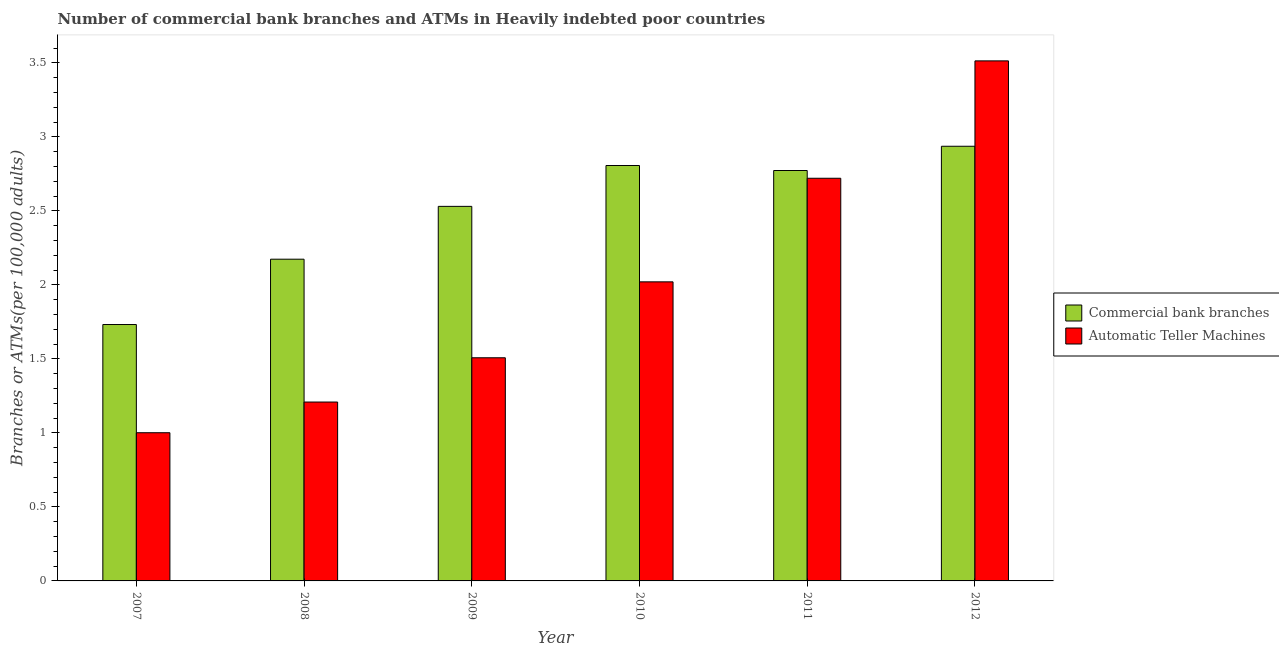How many different coloured bars are there?
Keep it short and to the point. 2. How many groups of bars are there?
Give a very brief answer. 6. Are the number of bars per tick equal to the number of legend labels?
Provide a short and direct response. Yes. How many bars are there on the 1st tick from the right?
Offer a very short reply. 2. What is the label of the 2nd group of bars from the left?
Your answer should be compact. 2008. In how many cases, is the number of bars for a given year not equal to the number of legend labels?
Provide a succinct answer. 0. What is the number of atms in 2010?
Offer a very short reply. 2.02. Across all years, what is the maximum number of commercal bank branches?
Keep it short and to the point. 2.94. Across all years, what is the minimum number of commercal bank branches?
Offer a very short reply. 1.73. What is the total number of commercal bank branches in the graph?
Offer a very short reply. 14.95. What is the difference between the number of commercal bank branches in 2008 and that in 2012?
Keep it short and to the point. -0.76. What is the difference between the number of commercal bank branches in 2009 and the number of atms in 2007?
Provide a succinct answer. 0.8. What is the average number of commercal bank branches per year?
Keep it short and to the point. 2.49. What is the ratio of the number of atms in 2007 to that in 2012?
Keep it short and to the point. 0.28. Is the number of atms in 2008 less than that in 2010?
Make the answer very short. Yes. Is the difference between the number of commercal bank branches in 2008 and 2009 greater than the difference between the number of atms in 2008 and 2009?
Offer a terse response. No. What is the difference between the highest and the second highest number of atms?
Offer a very short reply. 0.79. What is the difference between the highest and the lowest number of commercal bank branches?
Your answer should be compact. 1.2. In how many years, is the number of atms greater than the average number of atms taken over all years?
Provide a succinct answer. 3. Is the sum of the number of atms in 2007 and 2011 greater than the maximum number of commercal bank branches across all years?
Offer a terse response. Yes. What does the 1st bar from the left in 2008 represents?
Offer a terse response. Commercial bank branches. What does the 1st bar from the right in 2010 represents?
Keep it short and to the point. Automatic Teller Machines. How many bars are there?
Offer a very short reply. 12. Are all the bars in the graph horizontal?
Give a very brief answer. No. How many years are there in the graph?
Keep it short and to the point. 6. Are the values on the major ticks of Y-axis written in scientific E-notation?
Provide a succinct answer. No. Does the graph contain grids?
Offer a terse response. No. How many legend labels are there?
Keep it short and to the point. 2. What is the title of the graph?
Provide a succinct answer. Number of commercial bank branches and ATMs in Heavily indebted poor countries. What is the label or title of the Y-axis?
Your answer should be compact. Branches or ATMs(per 100,0 adults). What is the Branches or ATMs(per 100,000 adults) of Commercial bank branches in 2007?
Provide a succinct answer. 1.73. What is the Branches or ATMs(per 100,000 adults) in Automatic Teller Machines in 2007?
Offer a terse response. 1. What is the Branches or ATMs(per 100,000 adults) in Commercial bank branches in 2008?
Provide a succinct answer. 2.17. What is the Branches or ATMs(per 100,000 adults) in Automatic Teller Machines in 2008?
Provide a succinct answer. 1.21. What is the Branches or ATMs(per 100,000 adults) in Commercial bank branches in 2009?
Your answer should be very brief. 2.53. What is the Branches or ATMs(per 100,000 adults) of Automatic Teller Machines in 2009?
Your response must be concise. 1.51. What is the Branches or ATMs(per 100,000 adults) of Commercial bank branches in 2010?
Your answer should be compact. 2.81. What is the Branches or ATMs(per 100,000 adults) of Automatic Teller Machines in 2010?
Give a very brief answer. 2.02. What is the Branches or ATMs(per 100,000 adults) of Commercial bank branches in 2011?
Provide a short and direct response. 2.77. What is the Branches or ATMs(per 100,000 adults) of Automatic Teller Machines in 2011?
Ensure brevity in your answer.  2.72. What is the Branches or ATMs(per 100,000 adults) in Commercial bank branches in 2012?
Your response must be concise. 2.94. What is the Branches or ATMs(per 100,000 adults) of Automatic Teller Machines in 2012?
Provide a succinct answer. 3.51. Across all years, what is the maximum Branches or ATMs(per 100,000 adults) of Commercial bank branches?
Ensure brevity in your answer.  2.94. Across all years, what is the maximum Branches or ATMs(per 100,000 adults) in Automatic Teller Machines?
Keep it short and to the point. 3.51. Across all years, what is the minimum Branches or ATMs(per 100,000 adults) in Commercial bank branches?
Your response must be concise. 1.73. Across all years, what is the minimum Branches or ATMs(per 100,000 adults) of Automatic Teller Machines?
Your answer should be compact. 1. What is the total Branches or ATMs(per 100,000 adults) of Commercial bank branches in the graph?
Your response must be concise. 14.95. What is the total Branches or ATMs(per 100,000 adults) of Automatic Teller Machines in the graph?
Ensure brevity in your answer.  11.97. What is the difference between the Branches or ATMs(per 100,000 adults) of Commercial bank branches in 2007 and that in 2008?
Your answer should be compact. -0.44. What is the difference between the Branches or ATMs(per 100,000 adults) in Automatic Teller Machines in 2007 and that in 2008?
Your answer should be very brief. -0.21. What is the difference between the Branches or ATMs(per 100,000 adults) of Commercial bank branches in 2007 and that in 2009?
Give a very brief answer. -0.8. What is the difference between the Branches or ATMs(per 100,000 adults) of Automatic Teller Machines in 2007 and that in 2009?
Offer a terse response. -0.51. What is the difference between the Branches or ATMs(per 100,000 adults) of Commercial bank branches in 2007 and that in 2010?
Make the answer very short. -1.07. What is the difference between the Branches or ATMs(per 100,000 adults) in Automatic Teller Machines in 2007 and that in 2010?
Your answer should be compact. -1.02. What is the difference between the Branches or ATMs(per 100,000 adults) of Commercial bank branches in 2007 and that in 2011?
Your answer should be compact. -1.04. What is the difference between the Branches or ATMs(per 100,000 adults) in Automatic Teller Machines in 2007 and that in 2011?
Ensure brevity in your answer.  -1.72. What is the difference between the Branches or ATMs(per 100,000 adults) in Commercial bank branches in 2007 and that in 2012?
Keep it short and to the point. -1.2. What is the difference between the Branches or ATMs(per 100,000 adults) of Automatic Teller Machines in 2007 and that in 2012?
Your answer should be very brief. -2.51. What is the difference between the Branches or ATMs(per 100,000 adults) of Commercial bank branches in 2008 and that in 2009?
Keep it short and to the point. -0.36. What is the difference between the Branches or ATMs(per 100,000 adults) of Automatic Teller Machines in 2008 and that in 2009?
Give a very brief answer. -0.3. What is the difference between the Branches or ATMs(per 100,000 adults) of Commercial bank branches in 2008 and that in 2010?
Offer a very short reply. -0.63. What is the difference between the Branches or ATMs(per 100,000 adults) in Automatic Teller Machines in 2008 and that in 2010?
Your response must be concise. -0.81. What is the difference between the Branches or ATMs(per 100,000 adults) of Commercial bank branches in 2008 and that in 2011?
Your response must be concise. -0.6. What is the difference between the Branches or ATMs(per 100,000 adults) of Automatic Teller Machines in 2008 and that in 2011?
Give a very brief answer. -1.51. What is the difference between the Branches or ATMs(per 100,000 adults) of Commercial bank branches in 2008 and that in 2012?
Your answer should be compact. -0.76. What is the difference between the Branches or ATMs(per 100,000 adults) in Automatic Teller Machines in 2008 and that in 2012?
Your response must be concise. -2.31. What is the difference between the Branches or ATMs(per 100,000 adults) in Commercial bank branches in 2009 and that in 2010?
Your response must be concise. -0.28. What is the difference between the Branches or ATMs(per 100,000 adults) in Automatic Teller Machines in 2009 and that in 2010?
Offer a very short reply. -0.51. What is the difference between the Branches or ATMs(per 100,000 adults) of Commercial bank branches in 2009 and that in 2011?
Your answer should be very brief. -0.24. What is the difference between the Branches or ATMs(per 100,000 adults) in Automatic Teller Machines in 2009 and that in 2011?
Your answer should be very brief. -1.21. What is the difference between the Branches or ATMs(per 100,000 adults) in Commercial bank branches in 2009 and that in 2012?
Provide a short and direct response. -0.41. What is the difference between the Branches or ATMs(per 100,000 adults) in Automatic Teller Machines in 2009 and that in 2012?
Offer a very short reply. -2.01. What is the difference between the Branches or ATMs(per 100,000 adults) of Commercial bank branches in 2010 and that in 2011?
Offer a terse response. 0.03. What is the difference between the Branches or ATMs(per 100,000 adults) of Automatic Teller Machines in 2010 and that in 2011?
Provide a short and direct response. -0.7. What is the difference between the Branches or ATMs(per 100,000 adults) of Commercial bank branches in 2010 and that in 2012?
Ensure brevity in your answer.  -0.13. What is the difference between the Branches or ATMs(per 100,000 adults) in Automatic Teller Machines in 2010 and that in 2012?
Offer a terse response. -1.49. What is the difference between the Branches or ATMs(per 100,000 adults) in Commercial bank branches in 2011 and that in 2012?
Your answer should be compact. -0.16. What is the difference between the Branches or ATMs(per 100,000 adults) of Automatic Teller Machines in 2011 and that in 2012?
Your response must be concise. -0.79. What is the difference between the Branches or ATMs(per 100,000 adults) of Commercial bank branches in 2007 and the Branches or ATMs(per 100,000 adults) of Automatic Teller Machines in 2008?
Give a very brief answer. 0.52. What is the difference between the Branches or ATMs(per 100,000 adults) in Commercial bank branches in 2007 and the Branches or ATMs(per 100,000 adults) in Automatic Teller Machines in 2009?
Offer a terse response. 0.22. What is the difference between the Branches or ATMs(per 100,000 adults) of Commercial bank branches in 2007 and the Branches or ATMs(per 100,000 adults) of Automatic Teller Machines in 2010?
Offer a terse response. -0.29. What is the difference between the Branches or ATMs(per 100,000 adults) in Commercial bank branches in 2007 and the Branches or ATMs(per 100,000 adults) in Automatic Teller Machines in 2011?
Your response must be concise. -0.99. What is the difference between the Branches or ATMs(per 100,000 adults) in Commercial bank branches in 2007 and the Branches or ATMs(per 100,000 adults) in Automatic Teller Machines in 2012?
Ensure brevity in your answer.  -1.78. What is the difference between the Branches or ATMs(per 100,000 adults) in Commercial bank branches in 2008 and the Branches or ATMs(per 100,000 adults) in Automatic Teller Machines in 2009?
Keep it short and to the point. 0.67. What is the difference between the Branches or ATMs(per 100,000 adults) in Commercial bank branches in 2008 and the Branches or ATMs(per 100,000 adults) in Automatic Teller Machines in 2010?
Ensure brevity in your answer.  0.15. What is the difference between the Branches or ATMs(per 100,000 adults) of Commercial bank branches in 2008 and the Branches or ATMs(per 100,000 adults) of Automatic Teller Machines in 2011?
Offer a terse response. -0.55. What is the difference between the Branches or ATMs(per 100,000 adults) of Commercial bank branches in 2008 and the Branches or ATMs(per 100,000 adults) of Automatic Teller Machines in 2012?
Offer a very short reply. -1.34. What is the difference between the Branches or ATMs(per 100,000 adults) of Commercial bank branches in 2009 and the Branches or ATMs(per 100,000 adults) of Automatic Teller Machines in 2010?
Your answer should be very brief. 0.51. What is the difference between the Branches or ATMs(per 100,000 adults) in Commercial bank branches in 2009 and the Branches or ATMs(per 100,000 adults) in Automatic Teller Machines in 2011?
Your response must be concise. -0.19. What is the difference between the Branches or ATMs(per 100,000 adults) of Commercial bank branches in 2009 and the Branches or ATMs(per 100,000 adults) of Automatic Teller Machines in 2012?
Your answer should be compact. -0.98. What is the difference between the Branches or ATMs(per 100,000 adults) in Commercial bank branches in 2010 and the Branches or ATMs(per 100,000 adults) in Automatic Teller Machines in 2011?
Provide a succinct answer. 0.09. What is the difference between the Branches or ATMs(per 100,000 adults) in Commercial bank branches in 2010 and the Branches or ATMs(per 100,000 adults) in Automatic Teller Machines in 2012?
Your answer should be compact. -0.71. What is the difference between the Branches or ATMs(per 100,000 adults) of Commercial bank branches in 2011 and the Branches or ATMs(per 100,000 adults) of Automatic Teller Machines in 2012?
Offer a very short reply. -0.74. What is the average Branches or ATMs(per 100,000 adults) in Commercial bank branches per year?
Your answer should be compact. 2.49. What is the average Branches or ATMs(per 100,000 adults) in Automatic Teller Machines per year?
Give a very brief answer. 2. In the year 2007, what is the difference between the Branches or ATMs(per 100,000 adults) of Commercial bank branches and Branches or ATMs(per 100,000 adults) of Automatic Teller Machines?
Make the answer very short. 0.73. In the year 2008, what is the difference between the Branches or ATMs(per 100,000 adults) in Commercial bank branches and Branches or ATMs(per 100,000 adults) in Automatic Teller Machines?
Give a very brief answer. 0.96. In the year 2009, what is the difference between the Branches or ATMs(per 100,000 adults) of Commercial bank branches and Branches or ATMs(per 100,000 adults) of Automatic Teller Machines?
Your answer should be compact. 1.02. In the year 2010, what is the difference between the Branches or ATMs(per 100,000 adults) of Commercial bank branches and Branches or ATMs(per 100,000 adults) of Automatic Teller Machines?
Provide a short and direct response. 0.79. In the year 2011, what is the difference between the Branches or ATMs(per 100,000 adults) in Commercial bank branches and Branches or ATMs(per 100,000 adults) in Automatic Teller Machines?
Your answer should be compact. 0.05. In the year 2012, what is the difference between the Branches or ATMs(per 100,000 adults) in Commercial bank branches and Branches or ATMs(per 100,000 adults) in Automatic Teller Machines?
Give a very brief answer. -0.58. What is the ratio of the Branches or ATMs(per 100,000 adults) in Commercial bank branches in 2007 to that in 2008?
Provide a succinct answer. 0.8. What is the ratio of the Branches or ATMs(per 100,000 adults) in Automatic Teller Machines in 2007 to that in 2008?
Your response must be concise. 0.83. What is the ratio of the Branches or ATMs(per 100,000 adults) of Commercial bank branches in 2007 to that in 2009?
Make the answer very short. 0.68. What is the ratio of the Branches or ATMs(per 100,000 adults) of Automatic Teller Machines in 2007 to that in 2009?
Offer a terse response. 0.66. What is the ratio of the Branches or ATMs(per 100,000 adults) of Commercial bank branches in 2007 to that in 2010?
Ensure brevity in your answer.  0.62. What is the ratio of the Branches or ATMs(per 100,000 adults) of Automatic Teller Machines in 2007 to that in 2010?
Keep it short and to the point. 0.5. What is the ratio of the Branches or ATMs(per 100,000 adults) of Commercial bank branches in 2007 to that in 2011?
Your answer should be compact. 0.62. What is the ratio of the Branches or ATMs(per 100,000 adults) in Automatic Teller Machines in 2007 to that in 2011?
Your answer should be very brief. 0.37. What is the ratio of the Branches or ATMs(per 100,000 adults) in Commercial bank branches in 2007 to that in 2012?
Make the answer very short. 0.59. What is the ratio of the Branches or ATMs(per 100,000 adults) in Automatic Teller Machines in 2007 to that in 2012?
Ensure brevity in your answer.  0.28. What is the ratio of the Branches or ATMs(per 100,000 adults) of Commercial bank branches in 2008 to that in 2009?
Provide a short and direct response. 0.86. What is the ratio of the Branches or ATMs(per 100,000 adults) in Automatic Teller Machines in 2008 to that in 2009?
Make the answer very short. 0.8. What is the ratio of the Branches or ATMs(per 100,000 adults) of Commercial bank branches in 2008 to that in 2010?
Give a very brief answer. 0.77. What is the ratio of the Branches or ATMs(per 100,000 adults) of Automatic Teller Machines in 2008 to that in 2010?
Provide a short and direct response. 0.6. What is the ratio of the Branches or ATMs(per 100,000 adults) of Commercial bank branches in 2008 to that in 2011?
Offer a terse response. 0.78. What is the ratio of the Branches or ATMs(per 100,000 adults) in Automatic Teller Machines in 2008 to that in 2011?
Give a very brief answer. 0.44. What is the ratio of the Branches or ATMs(per 100,000 adults) of Commercial bank branches in 2008 to that in 2012?
Your answer should be compact. 0.74. What is the ratio of the Branches or ATMs(per 100,000 adults) in Automatic Teller Machines in 2008 to that in 2012?
Your answer should be compact. 0.34. What is the ratio of the Branches or ATMs(per 100,000 adults) in Commercial bank branches in 2009 to that in 2010?
Offer a terse response. 0.9. What is the ratio of the Branches or ATMs(per 100,000 adults) in Automatic Teller Machines in 2009 to that in 2010?
Make the answer very short. 0.75. What is the ratio of the Branches or ATMs(per 100,000 adults) in Commercial bank branches in 2009 to that in 2011?
Your answer should be compact. 0.91. What is the ratio of the Branches or ATMs(per 100,000 adults) of Automatic Teller Machines in 2009 to that in 2011?
Offer a terse response. 0.55. What is the ratio of the Branches or ATMs(per 100,000 adults) in Commercial bank branches in 2009 to that in 2012?
Provide a short and direct response. 0.86. What is the ratio of the Branches or ATMs(per 100,000 adults) in Automatic Teller Machines in 2009 to that in 2012?
Offer a terse response. 0.43. What is the ratio of the Branches or ATMs(per 100,000 adults) of Commercial bank branches in 2010 to that in 2011?
Ensure brevity in your answer.  1.01. What is the ratio of the Branches or ATMs(per 100,000 adults) in Automatic Teller Machines in 2010 to that in 2011?
Provide a short and direct response. 0.74. What is the ratio of the Branches or ATMs(per 100,000 adults) in Commercial bank branches in 2010 to that in 2012?
Your response must be concise. 0.96. What is the ratio of the Branches or ATMs(per 100,000 adults) in Automatic Teller Machines in 2010 to that in 2012?
Offer a very short reply. 0.58. What is the ratio of the Branches or ATMs(per 100,000 adults) of Commercial bank branches in 2011 to that in 2012?
Give a very brief answer. 0.94. What is the ratio of the Branches or ATMs(per 100,000 adults) in Automatic Teller Machines in 2011 to that in 2012?
Provide a succinct answer. 0.77. What is the difference between the highest and the second highest Branches or ATMs(per 100,000 adults) in Commercial bank branches?
Ensure brevity in your answer.  0.13. What is the difference between the highest and the second highest Branches or ATMs(per 100,000 adults) in Automatic Teller Machines?
Offer a very short reply. 0.79. What is the difference between the highest and the lowest Branches or ATMs(per 100,000 adults) in Commercial bank branches?
Your answer should be compact. 1.2. What is the difference between the highest and the lowest Branches or ATMs(per 100,000 adults) of Automatic Teller Machines?
Your answer should be very brief. 2.51. 